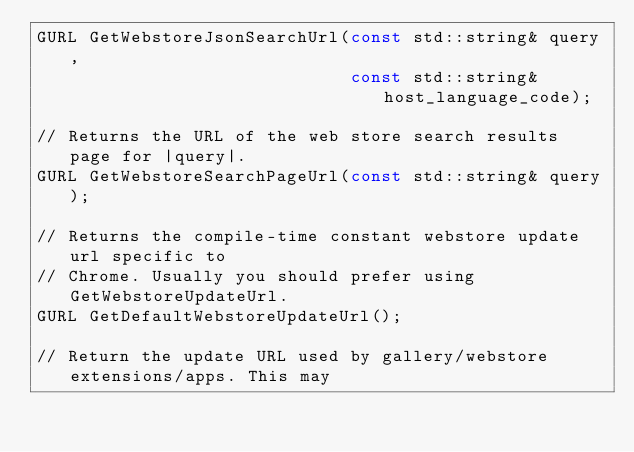<code> <loc_0><loc_0><loc_500><loc_500><_C_>GURL GetWebstoreJsonSearchUrl(const std::string& query,
                              const std::string& host_language_code);

// Returns the URL of the web store search results page for |query|.
GURL GetWebstoreSearchPageUrl(const std::string& query);

// Returns the compile-time constant webstore update url specific to
// Chrome. Usually you should prefer using GetWebstoreUpdateUrl.
GURL GetDefaultWebstoreUpdateUrl();

// Return the update URL used by gallery/webstore extensions/apps. This may</code> 